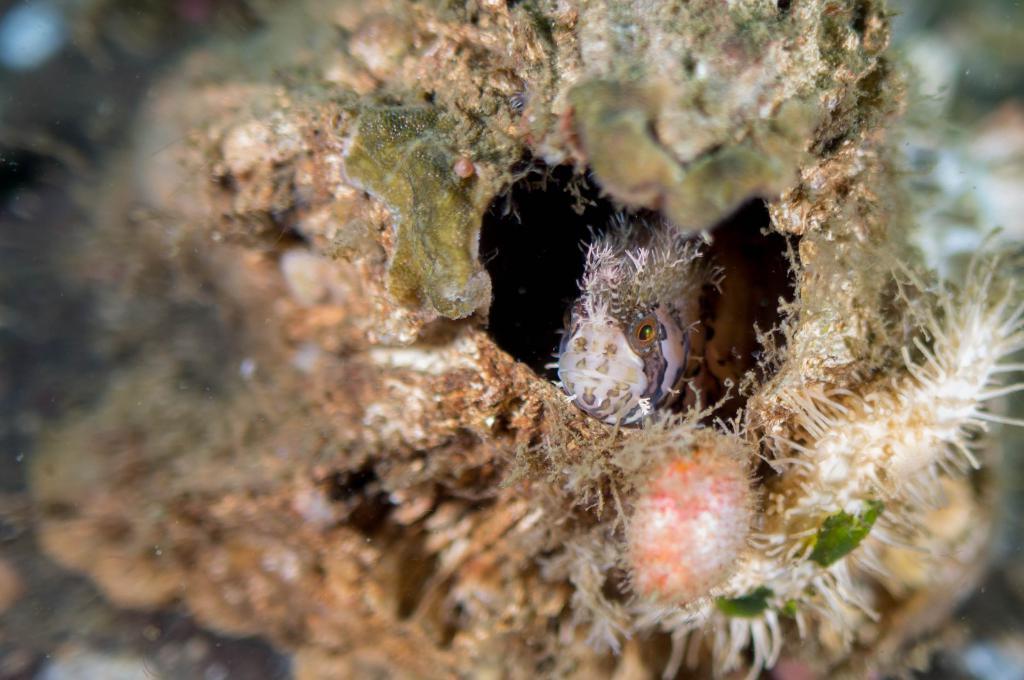How would you summarize this image in a sentence or two? In this image I can see the fish inside the rock. To the side I can see few aquatic plants. And there is a blurred background. 